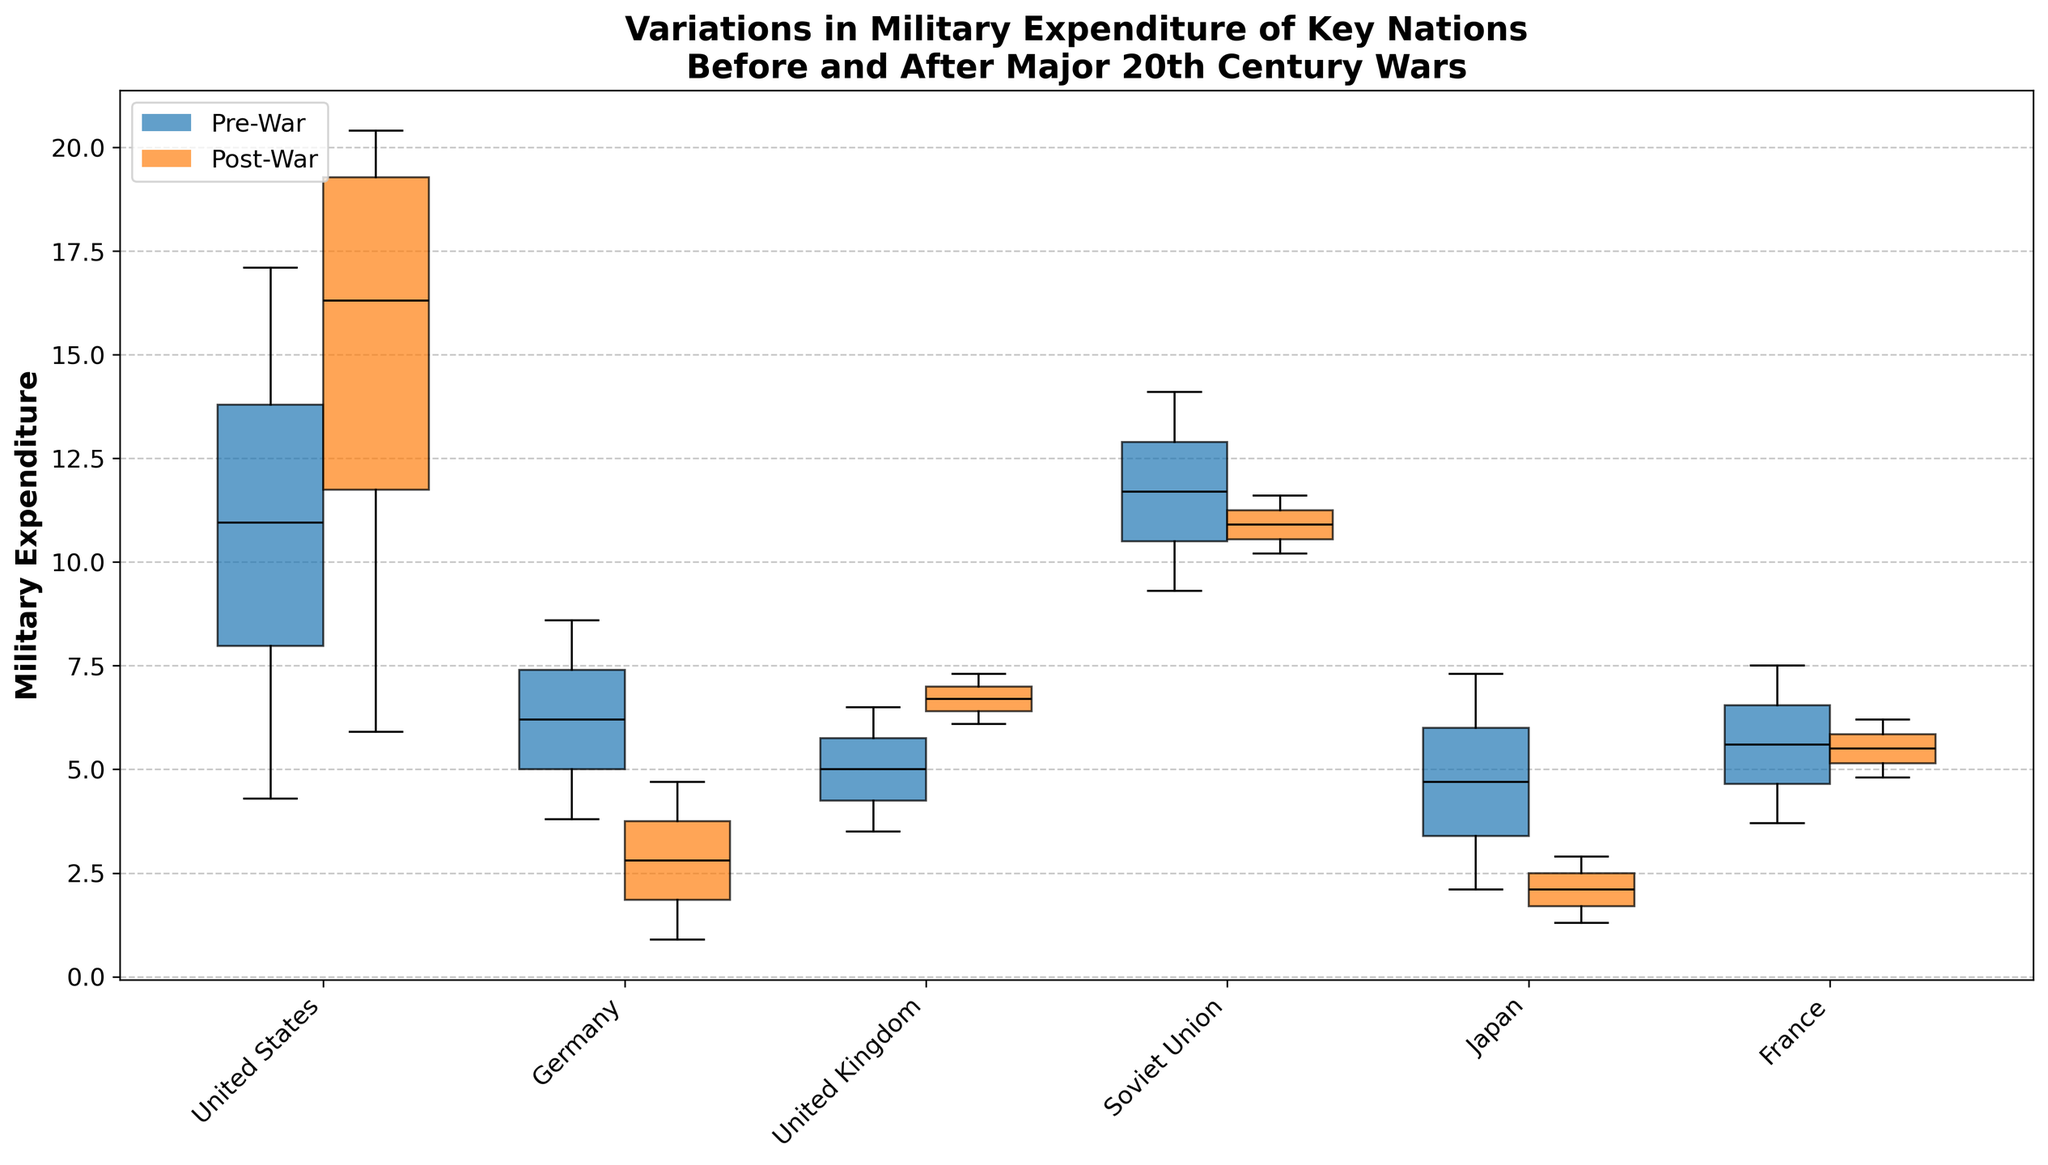What is the title of the figure? The title of the figure is positioned at the top and clearly reads "Variations in Military Expenditure of Key Nations Before and After Major 20th Century Wars".
Answer: Variations in Military Expenditure of Key Nations Before and After Major 20th Century Wars Which nations are included in the plot? The nations included in the plot are displayed along the x-axis as labels: United States, Germany, United Kingdom, Soviet Union, Japan, and France.
Answer: United States, Germany, United Kingdom, Soviet Union, Japan, France How are the periods 'Pre' and 'Post' represented in the plot? The periods 'Pre' and 'Post' are represented by two different colors for the box plots and are indicated in the legend. 'Pre-War' periods use the primary color, while 'Post-War' periods use the secondary color.
Answer: Different colors Which nation has the highest military expenditure in any period? The highest military expenditure in any period is indicated by the upper bounds of the box plots. The United States post-WWII has the highest value.
Answer: United States (Post-WWII) What is the median military expenditure for the United States post-WWI? The median value is indicated by the black line inside the post-WWI box plot for the United States, which is approximately 5.9.
Answer: ~5.9 Between France and Japan, which nation shows a greater reduction in military expenditure post-WWII? Comparing the reduction from pre-WWII to post-WWII for France and Japan, France reduces from approximately 7.5 to 6.2, whereas Japan reduces from 7.3 to 1.3. Thus, Japan shows a greater reduction.
Answer: Japan For the United Kingdom, how does military expenditure change from pre-WWI to post-WWI? The military expenditure for the United Kingdom increases from approximately 3.5 pre-WWI to 6.1 post-WWI.
Answer: Increases from ~3.5 to ~6.1 Which country's military expenditure shows an increase from pre-Korean to post-Korean periods? The Soviet Union exhibits an increase in military expenditure from approximately 9.3 pre-Korean to 11.6 post-Korean.
Answer: Soviet Union Is there a visible trend in the United States' military expenditure over the different periods shown (e.g., always increasing, decreasing, etc.)? The visual trend shows the United States' military expenditure consistently increasing across the periods, from pre-WWI to post-Vietnam, as indicated by higher median values in each subsequent period.
Answer: Increasing Among the nations presented, which one shows the lowest military expenditure post-WWII? By comparing the bottoms of the box plots for post-WWII among all nations, Japan shows the lowest military expenditure with approximately 1.3.
Answer: Japan 